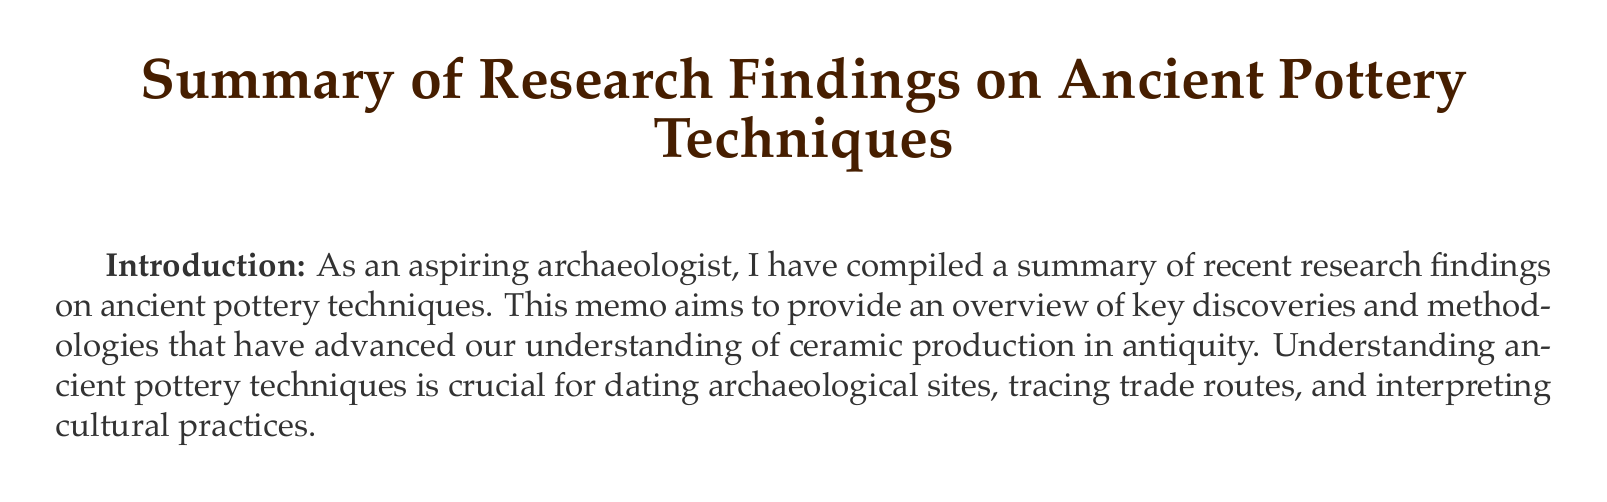What is the title of the memo? The title of the memo is provided at the beginning of the document.
Answer: Summary of Research Findings on Ancient Pottery Techniques Who are the authors of the key paper on Neolithic Pottery Production? The authors are mentioned within the findings section related to Neolithic Pottery Production.
Answer: Spataro, M., & Cubas, M What analytical method was used to study Roman terra sigillata? This is detailed in the main findings section under Roman Terra Sigillata Analysis.
Answer: New analytical methods What is one application of X-ray Fluorescence Spectroscopy mentioned in the document? The application is specified in the methodological advances section, detailing its purpose in analysis.
Answer: Non-destructive analysis of ceramic composition What emerging trend involves collaboration between two types of specialists? The trends in the future directions section specify the collaboration mentioned.
Answer: Archaeologists and materials scientists Which ancient civilization is associated with the production of Maya Blue pigment? The document specifies the civilization linked with Maya Blue pigment in the findings section.
Answer: Mesoamerican How many key findings are listed in the document? The main findings section contains the number of topics covered.
Answer: Three What is the potential impact of emerging trends mentioned in the memo? The document discusses how these trends could influence the understanding of ancient technologies.
Answer: Revolutionize our understanding of ancient ceramic technologies 